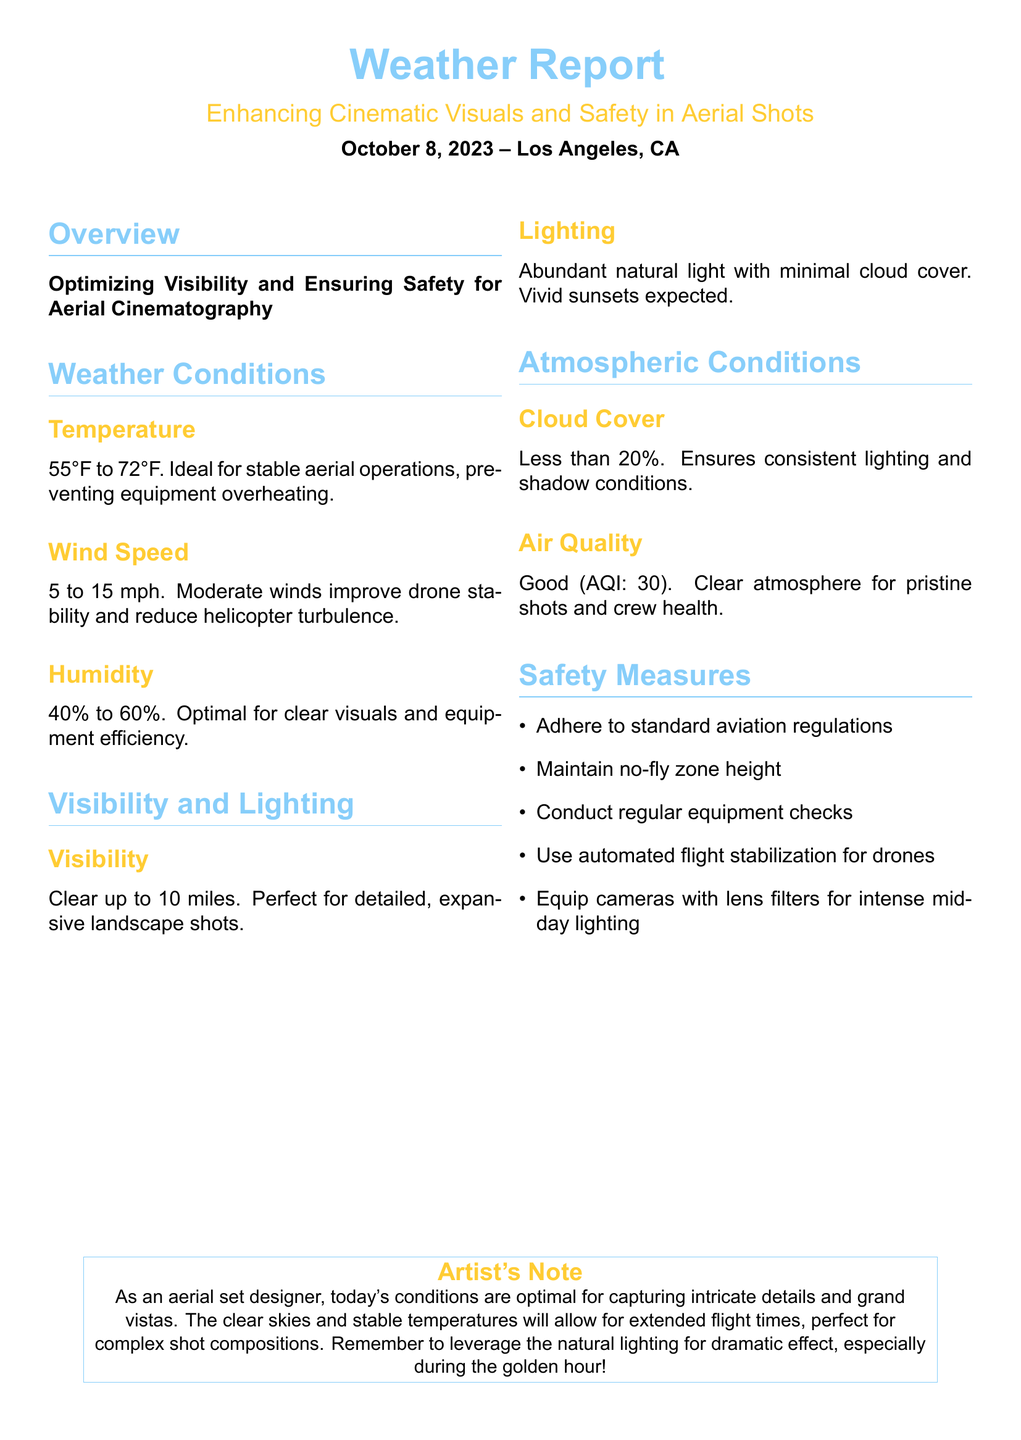What is the temperature range? The temperature range provided in the report is from 55°F to 72°F.
Answer: 55°F to 72°F What is the wind speed? The report mentions that the wind speed is between 5 to 15 mph.
Answer: 5 to 15 mph What is the visibility distance? The visibility is stated to be clear up to 10 miles.
Answer: 10 miles What is the air quality index (AQI)? The air quality is categorized as good with an AQI of 30.
Answer: 30 How much cloud cover is present? The report indicates that there is less than 20% cloud cover.
Answer: Less than 20% What atmospheric condition enhances lighting for cinematography? The report highlights that abundant natural light with minimal cloud cover enhances lighting for cinematography.
Answer: Abundant natural light What is the ideal humidity range mentioned? The humidity is noted to be between 40% to 60% for optimal visuals.
Answer: 40% to 60% Why are moderate winds beneficial? Moderate winds improve drone stability and reduce helicopter turbulence, enhancing safety and visuals.
Answer: Improve drone stability What safety measure should be taken with drones? The report advises using automated flight stabilization for drones.
Answer: Automated flight stabilization 